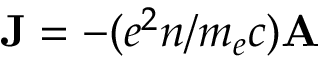<formula> <loc_0><loc_0><loc_500><loc_500>{ J } = - ( e ^ { 2 } n / m _ { e } c ) { A }</formula> 